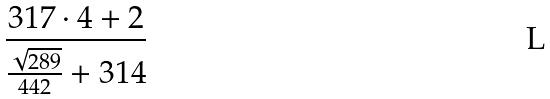<formula> <loc_0><loc_0><loc_500><loc_500>\frac { 3 1 7 \cdot 4 + 2 } { \frac { \sqrt { 2 8 9 } } { 4 4 2 } + 3 1 4 }</formula> 